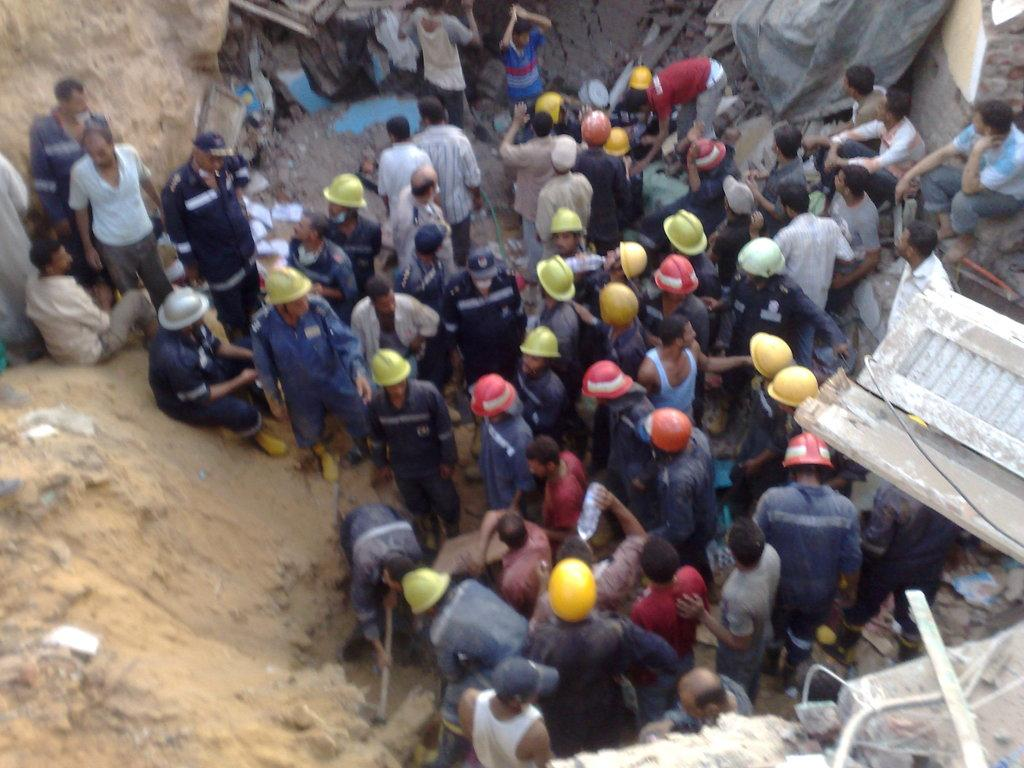What is the main subject of the image? The main subject of the image is a crowd. What can be seen on the ground in the image? There is mud in the image. What objects are present in the image that might be related to construction? There are rods in the image. What type of structure is visible in the image? There is a wall in the image. Where was the image likely taken? The image was likely taken near a construction site. What type of trail can be seen in the image? There is no trail visible in the image. What type of waste is being disposed of in the image? There is no waste disposal visible in the image. 